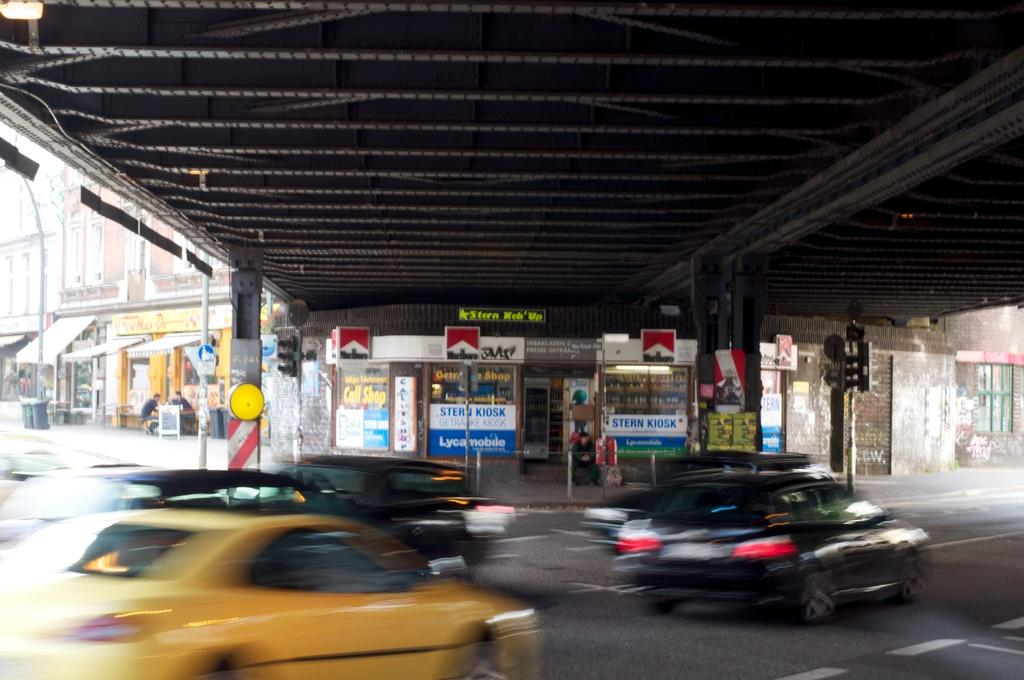<image>
Summarize the visual content of the image. Marlboro cigarettes are availabe at the store underneath the bridge. 